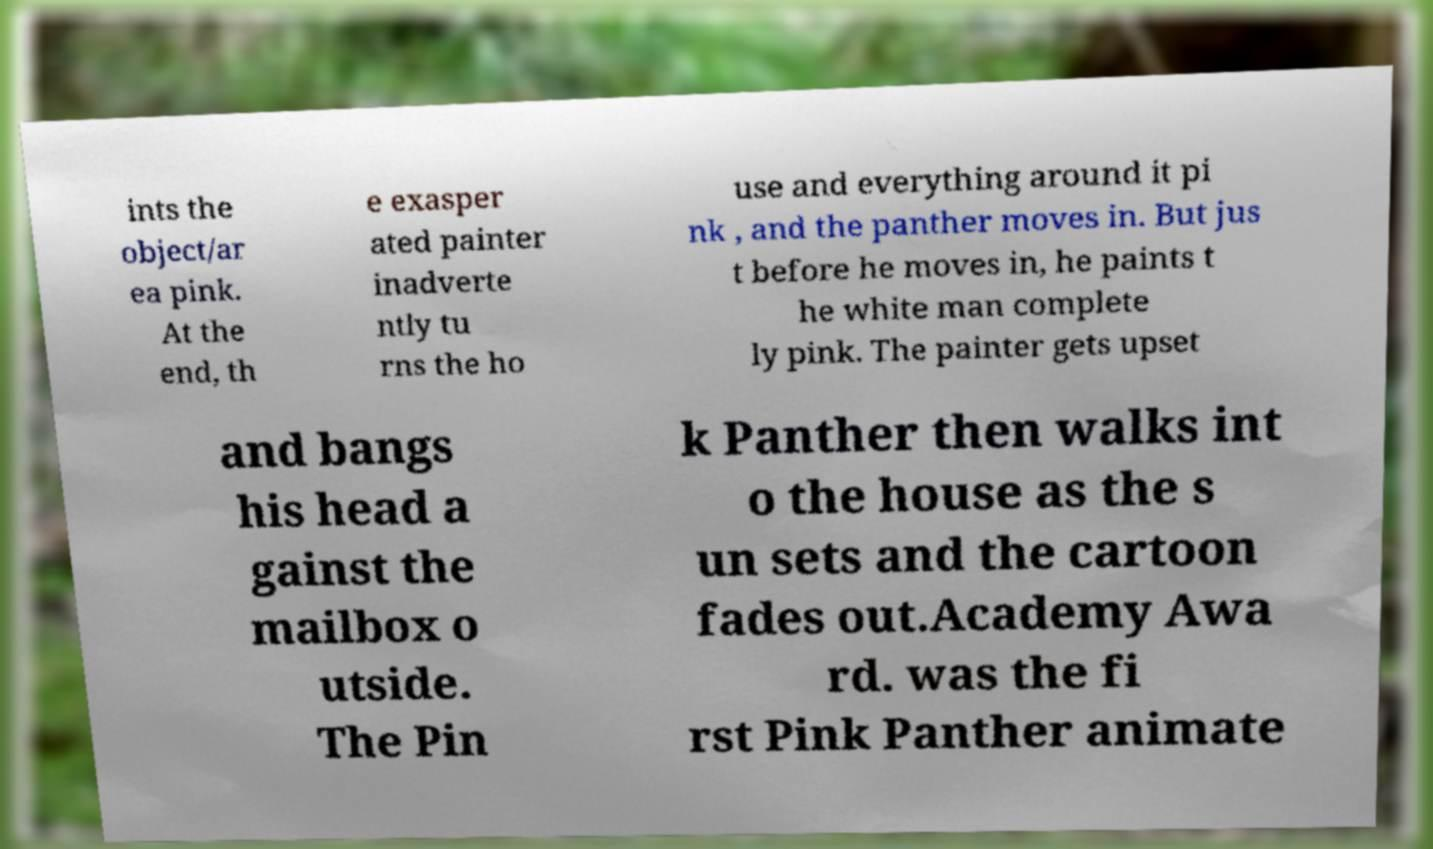I need the written content from this picture converted into text. Can you do that? ints the object/ar ea pink. At the end, th e exasper ated painter inadverte ntly tu rns the ho use and everything around it pi nk , and the panther moves in. But jus t before he moves in, he paints t he white man complete ly pink. The painter gets upset and bangs his head a gainst the mailbox o utside. The Pin k Panther then walks int o the house as the s un sets and the cartoon fades out.Academy Awa rd. was the fi rst Pink Panther animate 